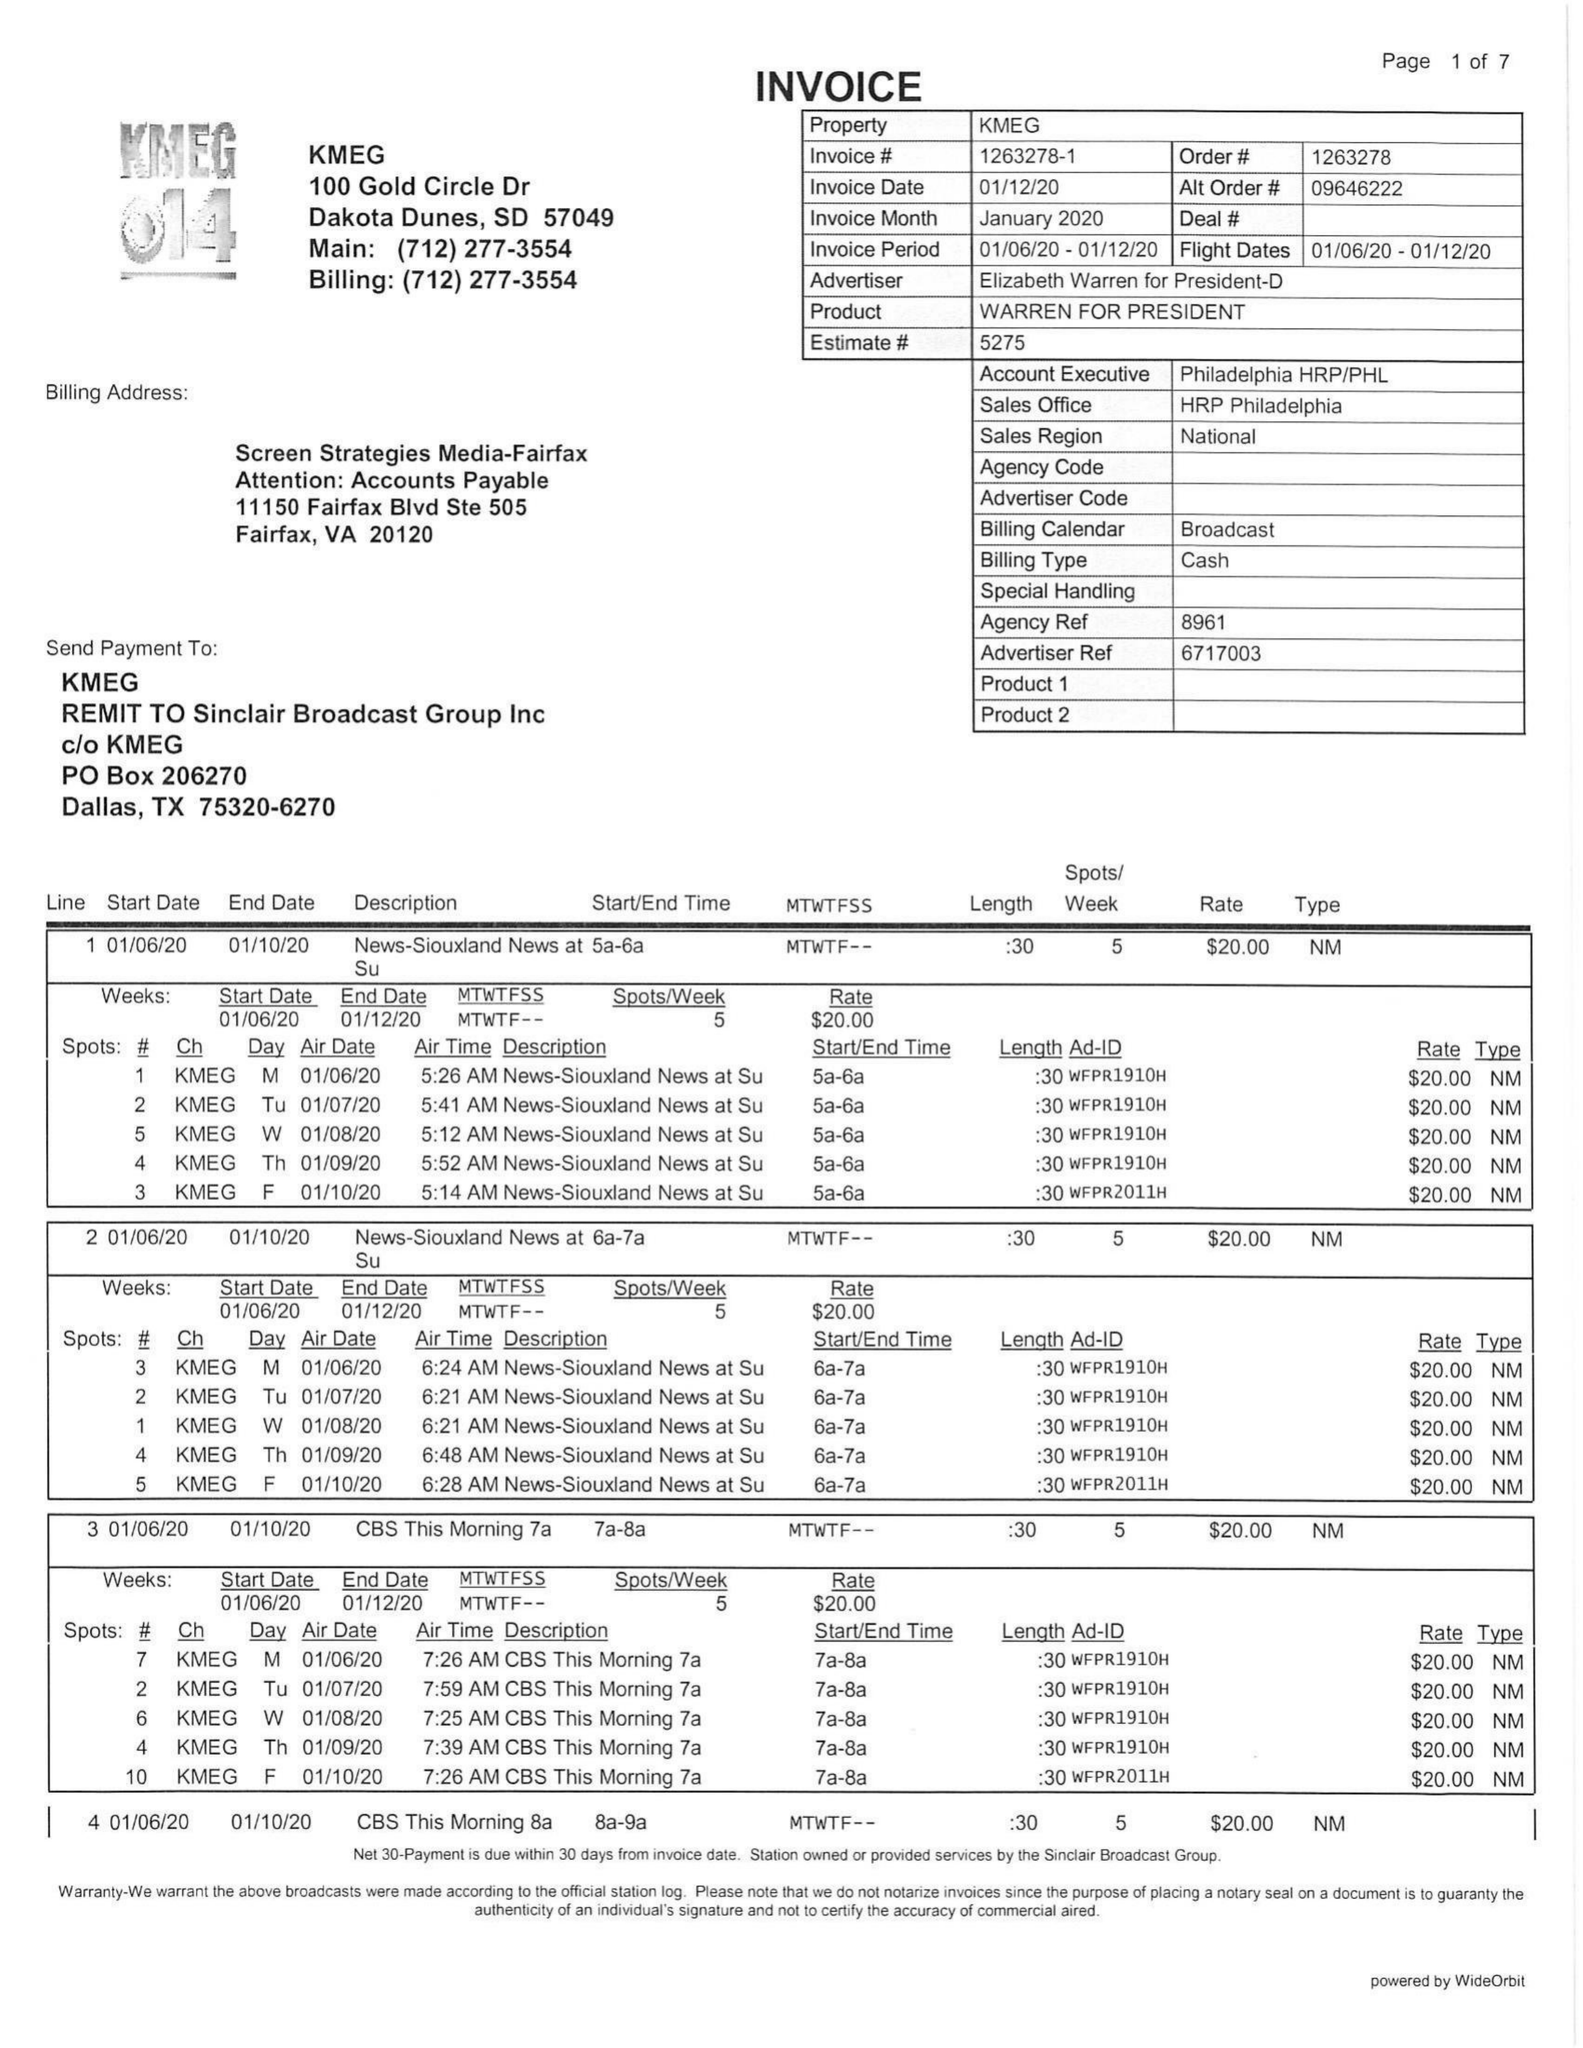What is the value for the flight_to?
Answer the question using a single word or phrase. 01/12/20 